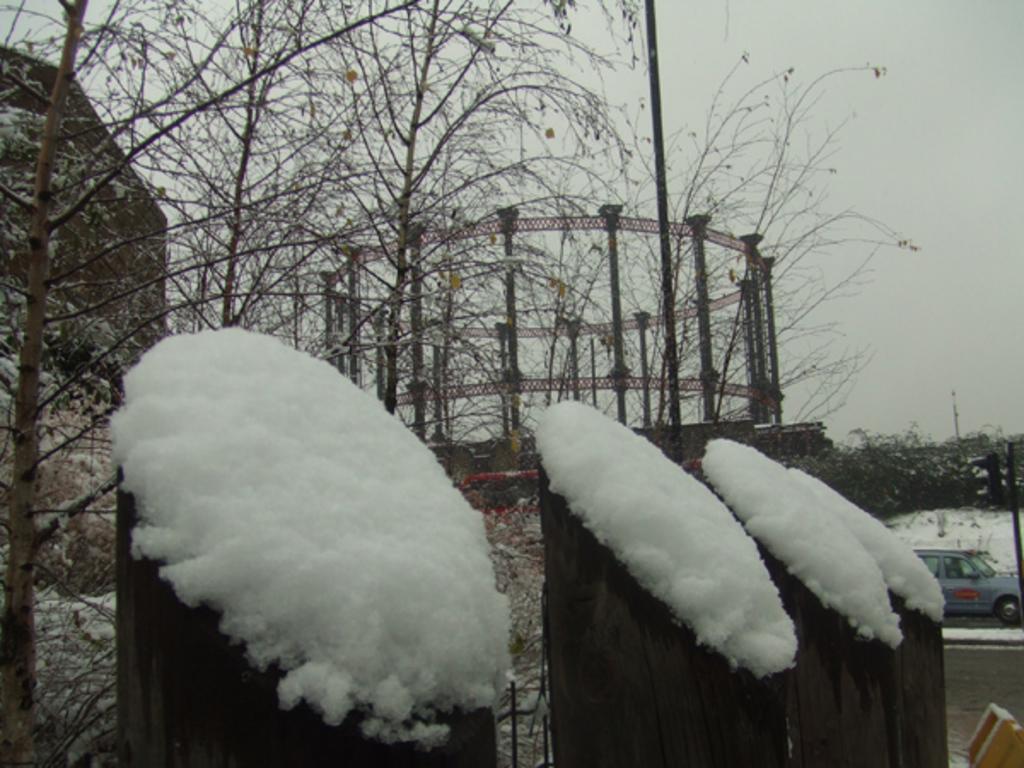Could you give a brief overview of what you see in this image? Here we can see wooden objects covered with snow and there is a car on the road. Here we can see trees, poles, and a metal object which is in circular shape. In the background there is sky. 